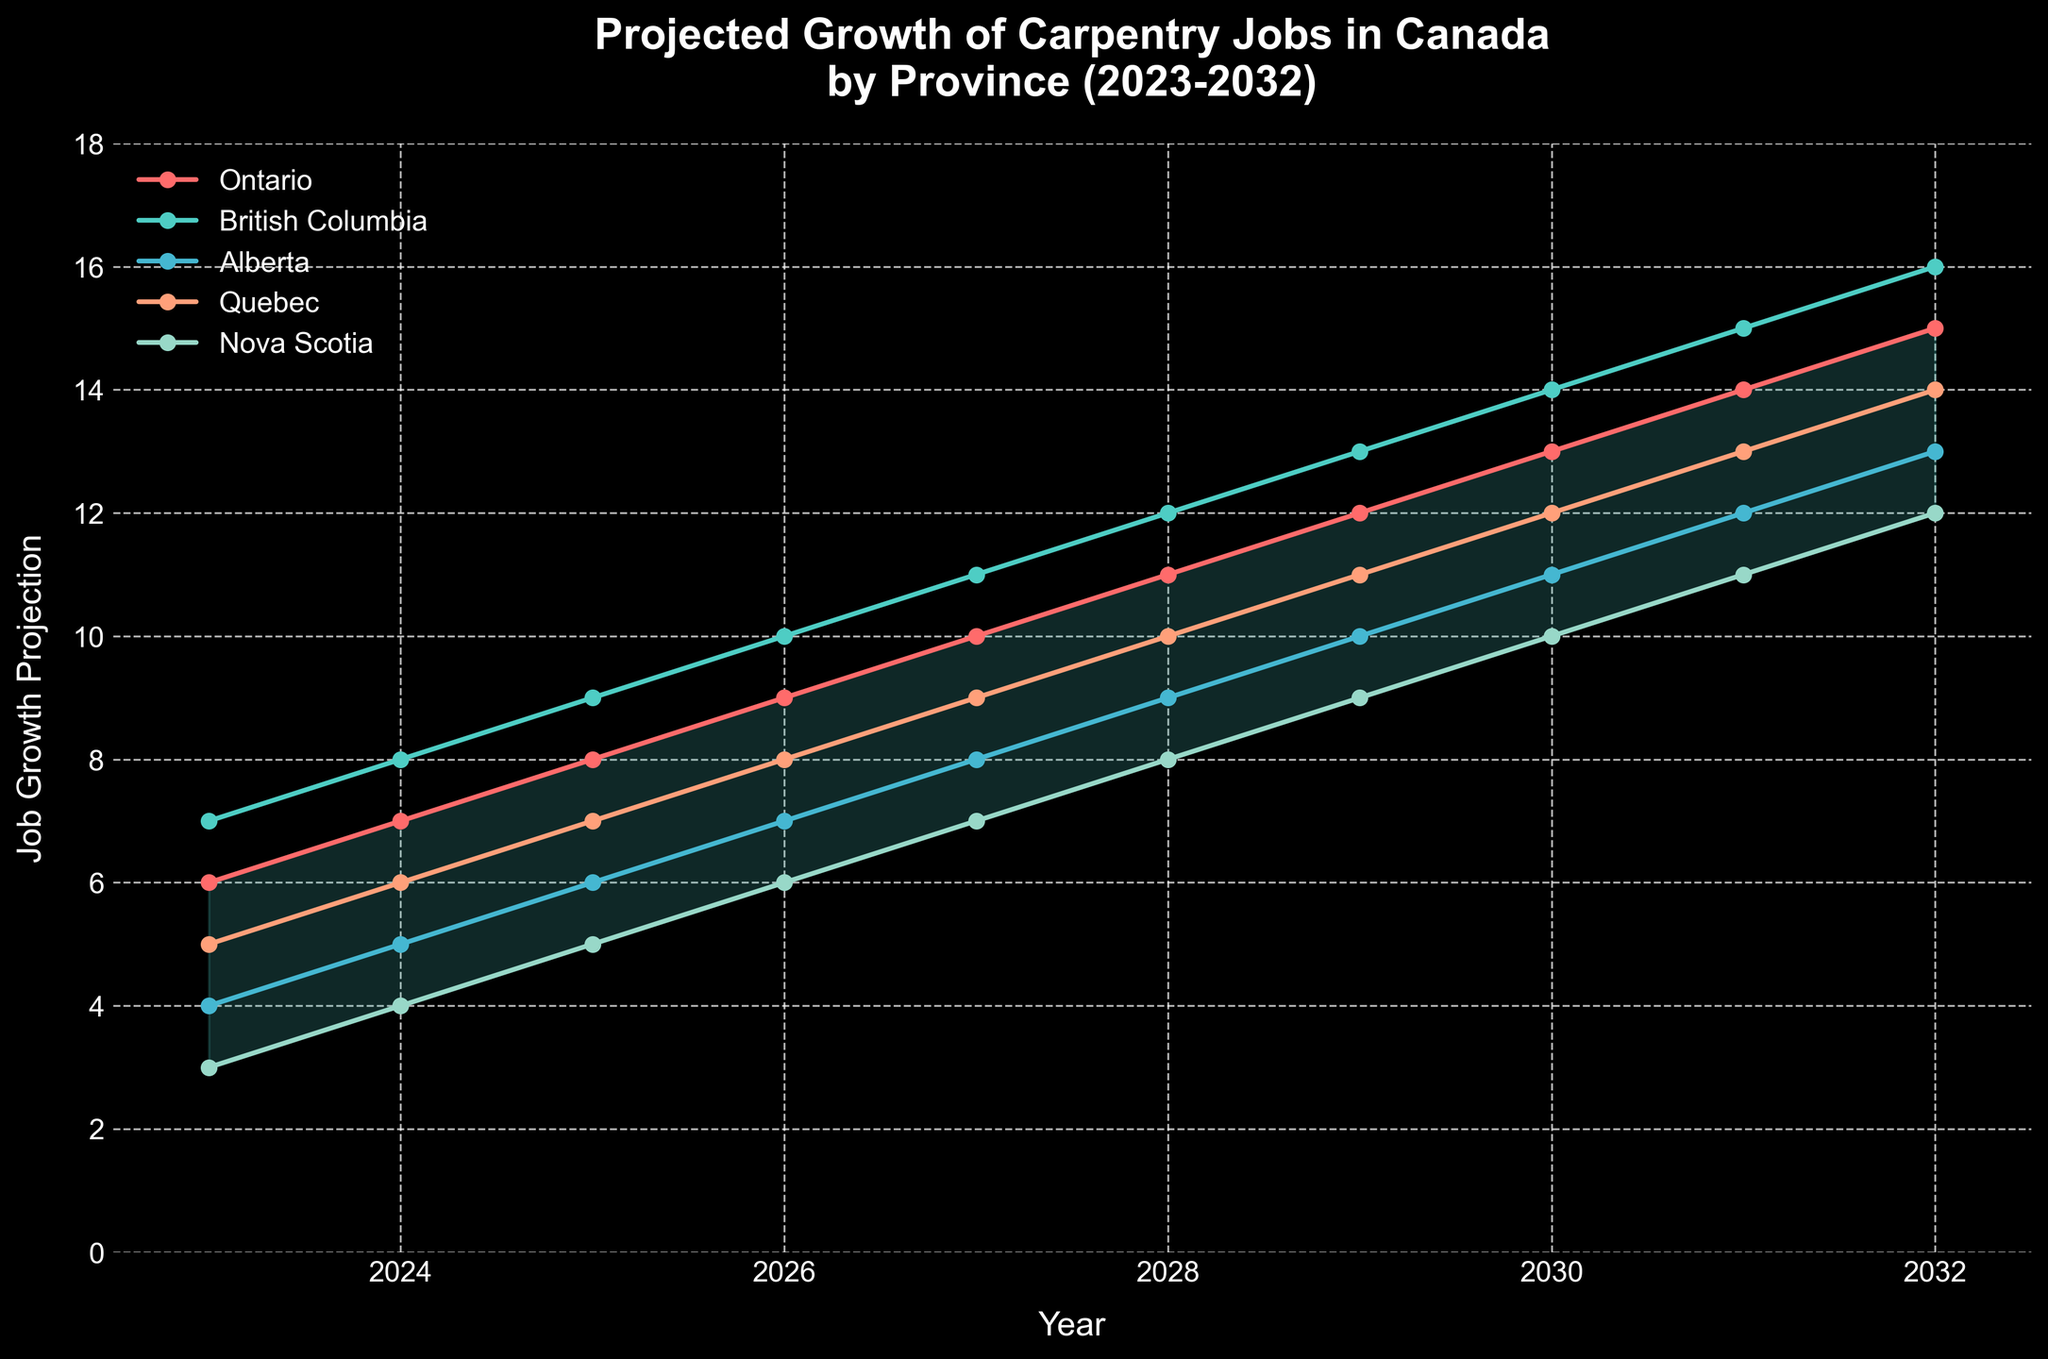what is the title of the plot? The title is usually displayed at the top of the plot. It describes what the chart represents.
Answer: Projected Growth of Carpentry Jobs in Canada by Province (2023-2032) what is the job growth projection for Nova Scotia in 2026? Locate the year 2026 on the x-axis and then find the corresponding value for Nova Scotia on the y-axis.
Answer: 6 in which year does Quebec's job growth projection reach 10? Identify the year on the x-axis where Quebec's job growth value reaches 10 on the y-axis.
Answer: 2028 Which province has the highest projected job growth in 2025? Compare the job growth projection values for all provinces in the year 2025.
Answer: British Columbia what's the average projected growth for Ontario between 2023 and 2027? Sum the job growth projections for Ontario from 2023 to 2027 and divide by the number of years (5). Calculation: (6 + 7 + 8 + 9 + 10) / 5 = 40 / 5 = 8
Answer: 8 how does Alberta's job growth projection in 2029 compare to its projection in 2023? Subtract Alberta's projection in 2023 from its projection in 2029 to determine the increase. Calculation: 10 - 4 = 6
Answer: 6 which province shows the least growth in 2032? Compare the job growth projection values for all provinces in the year 2032.
Answer: Nova Scotia How does the overall projected growth for Canada in 2032 compare to 2023? Subtract the projection value for Canada in 2023 from that in 2032 to get the overall increase. Calculation: 14 - 5 = 9
Answer: 9 what is the range of projected growth for all provinces in 2027? Identify the maximum and minimum job growth projections for all provinces in 2027, then subtract the minimum from the maximum. Calculation: 11 (British Columbia) - 7 (Nova Scotia) = 4
Answer: 4 